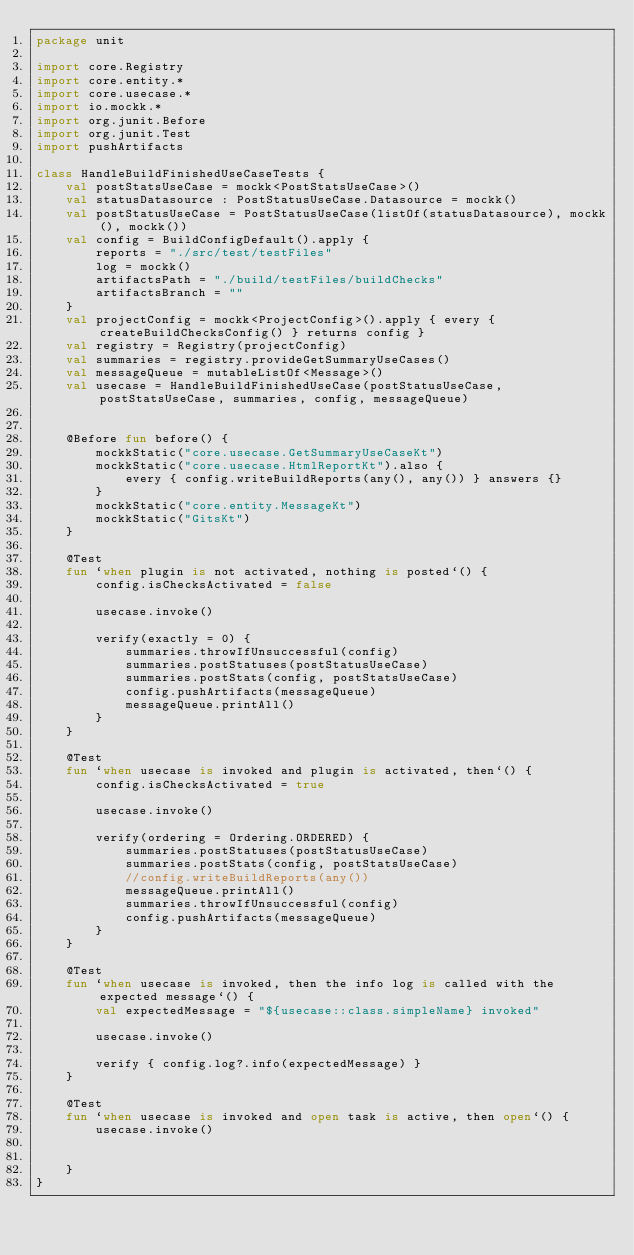Convert code to text. <code><loc_0><loc_0><loc_500><loc_500><_Kotlin_>package unit

import core.Registry
import core.entity.*
import core.usecase.*
import io.mockk.*
import org.junit.Before
import org.junit.Test
import pushArtifacts

class HandleBuildFinishedUseCaseTests {
    val postStatsUseCase = mockk<PostStatsUseCase>()
    val statusDatasource : PostStatusUseCase.Datasource = mockk()
    val postStatusUseCase = PostStatusUseCase(listOf(statusDatasource), mockk(), mockk())
    val config = BuildConfigDefault().apply {
        reports = "./src/test/testFiles"
        log = mockk()
        artifactsPath = "./build/testFiles/buildChecks"
        artifactsBranch = ""
    }
    val projectConfig = mockk<ProjectConfig>().apply { every { createBuildChecksConfig() } returns config }
    val registry = Registry(projectConfig)
    val summaries = registry.provideGetSummaryUseCases()
    val messageQueue = mutableListOf<Message>()
    val usecase = HandleBuildFinishedUseCase(postStatusUseCase, postStatsUseCase, summaries, config, messageQueue)


    @Before fun before() {
        mockkStatic("core.usecase.GetSummaryUseCaseKt")
        mockkStatic("core.usecase.HtmlReportKt").also {
            every { config.writeBuildReports(any(), any()) } answers {}
        }
        mockkStatic("core.entity.MessageKt")
        mockkStatic("GitsKt")
    }

    @Test
    fun `when plugin is not activated, nothing is posted`() {
        config.isChecksActivated = false

        usecase.invoke()

        verify(exactly = 0) {
            summaries.throwIfUnsuccessful(config)
            summaries.postStatuses(postStatusUseCase)
            summaries.postStats(config, postStatsUseCase)
            config.pushArtifacts(messageQueue)
            messageQueue.printAll()
        }
    }

    @Test
    fun `when usecase is invoked and plugin is activated, then`() {
        config.isChecksActivated = true

        usecase.invoke()

        verify(ordering = Ordering.ORDERED) {
            summaries.postStatuses(postStatusUseCase)
            summaries.postStats(config, postStatsUseCase)
            //config.writeBuildReports(any())
            messageQueue.printAll()
            summaries.throwIfUnsuccessful(config)
            config.pushArtifacts(messageQueue)
        }
    }

    @Test
    fun `when usecase is invoked, then the info log is called with the expected message`() {
        val expectedMessage = "${usecase::class.simpleName} invoked"

        usecase.invoke()

        verify { config.log?.info(expectedMessage) }
    }

    @Test
    fun `when usecase is invoked and open task is active, then open`() {
        usecase.invoke()


    }
}

</code> 